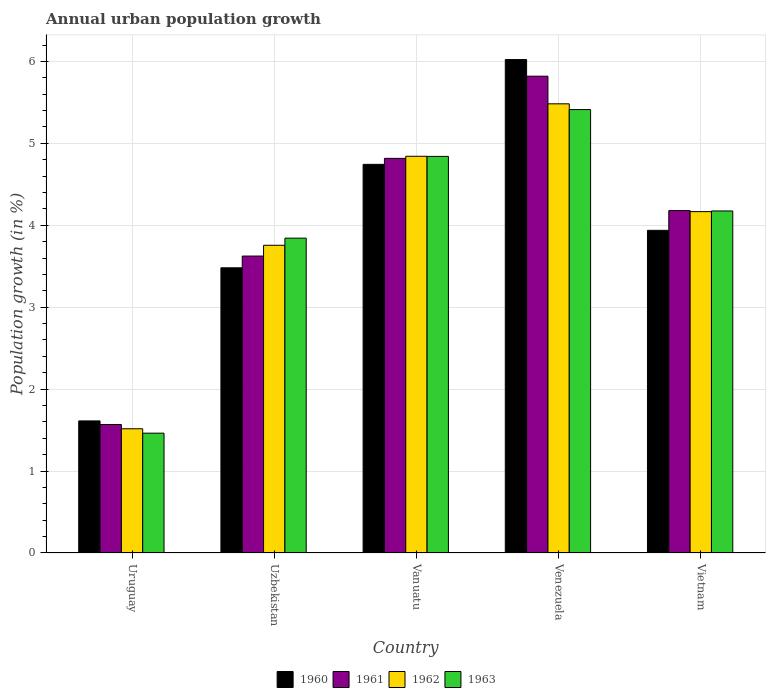Are the number of bars per tick equal to the number of legend labels?
Your answer should be compact. Yes. How many bars are there on the 2nd tick from the left?
Keep it short and to the point. 4. What is the label of the 5th group of bars from the left?
Your answer should be compact. Vietnam. What is the percentage of urban population growth in 1963 in Uzbekistan?
Provide a short and direct response. 3.84. Across all countries, what is the maximum percentage of urban population growth in 1962?
Ensure brevity in your answer.  5.48. Across all countries, what is the minimum percentage of urban population growth in 1962?
Your answer should be compact. 1.52. In which country was the percentage of urban population growth in 1962 maximum?
Keep it short and to the point. Venezuela. In which country was the percentage of urban population growth in 1961 minimum?
Give a very brief answer. Uruguay. What is the total percentage of urban population growth in 1962 in the graph?
Provide a short and direct response. 19.76. What is the difference between the percentage of urban population growth in 1962 in Uruguay and that in Venezuela?
Provide a succinct answer. -3.97. What is the difference between the percentage of urban population growth in 1962 in Venezuela and the percentage of urban population growth in 1961 in Uruguay?
Offer a very short reply. 3.91. What is the average percentage of urban population growth in 1960 per country?
Your response must be concise. 3.96. What is the difference between the percentage of urban population growth of/in 1960 and percentage of urban population growth of/in 1961 in Uzbekistan?
Give a very brief answer. -0.14. What is the ratio of the percentage of urban population growth in 1961 in Uzbekistan to that in Vietnam?
Make the answer very short. 0.87. Is the percentage of urban population growth in 1961 in Venezuela less than that in Vietnam?
Provide a short and direct response. No. Is the difference between the percentage of urban population growth in 1960 in Uzbekistan and Vanuatu greater than the difference between the percentage of urban population growth in 1961 in Uzbekistan and Vanuatu?
Keep it short and to the point. No. What is the difference between the highest and the second highest percentage of urban population growth in 1962?
Provide a succinct answer. -0.68. What is the difference between the highest and the lowest percentage of urban population growth in 1960?
Give a very brief answer. 4.41. In how many countries, is the percentage of urban population growth in 1963 greater than the average percentage of urban population growth in 1963 taken over all countries?
Provide a succinct answer. 3. What does the 2nd bar from the right in Vietnam represents?
Provide a short and direct response. 1962. How many bars are there?
Provide a short and direct response. 20. Are the values on the major ticks of Y-axis written in scientific E-notation?
Your response must be concise. No. Does the graph contain any zero values?
Your answer should be compact. No. Does the graph contain grids?
Your answer should be very brief. Yes. How are the legend labels stacked?
Give a very brief answer. Horizontal. What is the title of the graph?
Your response must be concise. Annual urban population growth. What is the label or title of the Y-axis?
Offer a terse response. Population growth (in %). What is the Population growth (in %) in 1960 in Uruguay?
Offer a terse response. 1.61. What is the Population growth (in %) in 1961 in Uruguay?
Provide a succinct answer. 1.57. What is the Population growth (in %) of 1962 in Uruguay?
Provide a succinct answer. 1.52. What is the Population growth (in %) in 1963 in Uruguay?
Make the answer very short. 1.46. What is the Population growth (in %) in 1960 in Uzbekistan?
Give a very brief answer. 3.48. What is the Population growth (in %) of 1961 in Uzbekistan?
Give a very brief answer. 3.62. What is the Population growth (in %) of 1962 in Uzbekistan?
Provide a short and direct response. 3.76. What is the Population growth (in %) of 1963 in Uzbekistan?
Your response must be concise. 3.84. What is the Population growth (in %) in 1960 in Vanuatu?
Your response must be concise. 4.74. What is the Population growth (in %) in 1961 in Vanuatu?
Offer a terse response. 4.82. What is the Population growth (in %) in 1962 in Vanuatu?
Your response must be concise. 4.84. What is the Population growth (in %) of 1963 in Vanuatu?
Your response must be concise. 4.84. What is the Population growth (in %) in 1960 in Venezuela?
Offer a very short reply. 6.02. What is the Population growth (in %) in 1961 in Venezuela?
Keep it short and to the point. 5.82. What is the Population growth (in %) of 1962 in Venezuela?
Offer a very short reply. 5.48. What is the Population growth (in %) of 1963 in Venezuela?
Provide a succinct answer. 5.41. What is the Population growth (in %) of 1960 in Vietnam?
Provide a succinct answer. 3.94. What is the Population growth (in %) of 1961 in Vietnam?
Your response must be concise. 4.18. What is the Population growth (in %) of 1962 in Vietnam?
Keep it short and to the point. 4.17. What is the Population growth (in %) of 1963 in Vietnam?
Your answer should be compact. 4.17. Across all countries, what is the maximum Population growth (in %) in 1960?
Offer a terse response. 6.02. Across all countries, what is the maximum Population growth (in %) of 1961?
Offer a terse response. 5.82. Across all countries, what is the maximum Population growth (in %) of 1962?
Provide a succinct answer. 5.48. Across all countries, what is the maximum Population growth (in %) in 1963?
Keep it short and to the point. 5.41. Across all countries, what is the minimum Population growth (in %) in 1960?
Offer a very short reply. 1.61. Across all countries, what is the minimum Population growth (in %) in 1961?
Offer a very short reply. 1.57. Across all countries, what is the minimum Population growth (in %) of 1962?
Provide a succinct answer. 1.52. Across all countries, what is the minimum Population growth (in %) in 1963?
Your answer should be compact. 1.46. What is the total Population growth (in %) in 1960 in the graph?
Provide a short and direct response. 19.8. What is the total Population growth (in %) in 1961 in the graph?
Make the answer very short. 20.01. What is the total Population growth (in %) of 1962 in the graph?
Keep it short and to the point. 19.76. What is the total Population growth (in %) of 1963 in the graph?
Your answer should be compact. 19.73. What is the difference between the Population growth (in %) of 1960 in Uruguay and that in Uzbekistan?
Make the answer very short. -1.87. What is the difference between the Population growth (in %) in 1961 in Uruguay and that in Uzbekistan?
Offer a terse response. -2.06. What is the difference between the Population growth (in %) of 1962 in Uruguay and that in Uzbekistan?
Offer a very short reply. -2.24. What is the difference between the Population growth (in %) of 1963 in Uruguay and that in Uzbekistan?
Provide a succinct answer. -2.38. What is the difference between the Population growth (in %) in 1960 in Uruguay and that in Vanuatu?
Make the answer very short. -3.13. What is the difference between the Population growth (in %) of 1961 in Uruguay and that in Vanuatu?
Offer a very short reply. -3.25. What is the difference between the Population growth (in %) in 1962 in Uruguay and that in Vanuatu?
Keep it short and to the point. -3.33. What is the difference between the Population growth (in %) in 1963 in Uruguay and that in Vanuatu?
Your response must be concise. -3.38. What is the difference between the Population growth (in %) of 1960 in Uruguay and that in Venezuela?
Give a very brief answer. -4.41. What is the difference between the Population growth (in %) in 1961 in Uruguay and that in Venezuela?
Make the answer very short. -4.25. What is the difference between the Population growth (in %) of 1962 in Uruguay and that in Venezuela?
Provide a succinct answer. -3.97. What is the difference between the Population growth (in %) in 1963 in Uruguay and that in Venezuela?
Keep it short and to the point. -3.95. What is the difference between the Population growth (in %) in 1960 in Uruguay and that in Vietnam?
Your answer should be compact. -2.33. What is the difference between the Population growth (in %) in 1961 in Uruguay and that in Vietnam?
Make the answer very short. -2.61. What is the difference between the Population growth (in %) of 1962 in Uruguay and that in Vietnam?
Give a very brief answer. -2.65. What is the difference between the Population growth (in %) of 1963 in Uruguay and that in Vietnam?
Keep it short and to the point. -2.71. What is the difference between the Population growth (in %) in 1960 in Uzbekistan and that in Vanuatu?
Make the answer very short. -1.26. What is the difference between the Population growth (in %) of 1961 in Uzbekistan and that in Vanuatu?
Provide a succinct answer. -1.19. What is the difference between the Population growth (in %) of 1962 in Uzbekistan and that in Vanuatu?
Your response must be concise. -1.09. What is the difference between the Population growth (in %) in 1963 in Uzbekistan and that in Vanuatu?
Give a very brief answer. -1. What is the difference between the Population growth (in %) of 1960 in Uzbekistan and that in Venezuela?
Offer a very short reply. -2.54. What is the difference between the Population growth (in %) of 1961 in Uzbekistan and that in Venezuela?
Your response must be concise. -2.2. What is the difference between the Population growth (in %) of 1962 in Uzbekistan and that in Venezuela?
Offer a very short reply. -1.73. What is the difference between the Population growth (in %) in 1963 in Uzbekistan and that in Venezuela?
Ensure brevity in your answer.  -1.57. What is the difference between the Population growth (in %) in 1960 in Uzbekistan and that in Vietnam?
Your answer should be very brief. -0.46. What is the difference between the Population growth (in %) of 1961 in Uzbekistan and that in Vietnam?
Your answer should be compact. -0.56. What is the difference between the Population growth (in %) in 1962 in Uzbekistan and that in Vietnam?
Keep it short and to the point. -0.41. What is the difference between the Population growth (in %) in 1963 in Uzbekistan and that in Vietnam?
Your response must be concise. -0.33. What is the difference between the Population growth (in %) of 1960 in Vanuatu and that in Venezuela?
Keep it short and to the point. -1.28. What is the difference between the Population growth (in %) in 1961 in Vanuatu and that in Venezuela?
Keep it short and to the point. -1. What is the difference between the Population growth (in %) in 1962 in Vanuatu and that in Venezuela?
Make the answer very short. -0.64. What is the difference between the Population growth (in %) in 1963 in Vanuatu and that in Venezuela?
Offer a terse response. -0.57. What is the difference between the Population growth (in %) of 1960 in Vanuatu and that in Vietnam?
Ensure brevity in your answer.  0.81. What is the difference between the Population growth (in %) in 1961 in Vanuatu and that in Vietnam?
Your answer should be compact. 0.64. What is the difference between the Population growth (in %) of 1962 in Vanuatu and that in Vietnam?
Offer a terse response. 0.68. What is the difference between the Population growth (in %) of 1963 in Vanuatu and that in Vietnam?
Ensure brevity in your answer.  0.67. What is the difference between the Population growth (in %) in 1960 in Venezuela and that in Vietnam?
Provide a short and direct response. 2.08. What is the difference between the Population growth (in %) in 1961 in Venezuela and that in Vietnam?
Provide a succinct answer. 1.64. What is the difference between the Population growth (in %) in 1962 in Venezuela and that in Vietnam?
Your response must be concise. 1.32. What is the difference between the Population growth (in %) of 1963 in Venezuela and that in Vietnam?
Your answer should be compact. 1.24. What is the difference between the Population growth (in %) in 1960 in Uruguay and the Population growth (in %) in 1961 in Uzbekistan?
Provide a short and direct response. -2.01. What is the difference between the Population growth (in %) of 1960 in Uruguay and the Population growth (in %) of 1962 in Uzbekistan?
Your answer should be very brief. -2.14. What is the difference between the Population growth (in %) of 1960 in Uruguay and the Population growth (in %) of 1963 in Uzbekistan?
Your answer should be very brief. -2.23. What is the difference between the Population growth (in %) of 1961 in Uruguay and the Population growth (in %) of 1962 in Uzbekistan?
Keep it short and to the point. -2.19. What is the difference between the Population growth (in %) in 1961 in Uruguay and the Population growth (in %) in 1963 in Uzbekistan?
Ensure brevity in your answer.  -2.27. What is the difference between the Population growth (in %) of 1962 in Uruguay and the Population growth (in %) of 1963 in Uzbekistan?
Ensure brevity in your answer.  -2.33. What is the difference between the Population growth (in %) in 1960 in Uruguay and the Population growth (in %) in 1961 in Vanuatu?
Provide a succinct answer. -3.2. What is the difference between the Population growth (in %) of 1960 in Uruguay and the Population growth (in %) of 1962 in Vanuatu?
Offer a very short reply. -3.23. What is the difference between the Population growth (in %) in 1960 in Uruguay and the Population growth (in %) in 1963 in Vanuatu?
Your answer should be compact. -3.23. What is the difference between the Population growth (in %) in 1961 in Uruguay and the Population growth (in %) in 1962 in Vanuatu?
Offer a very short reply. -3.27. What is the difference between the Population growth (in %) in 1961 in Uruguay and the Population growth (in %) in 1963 in Vanuatu?
Offer a terse response. -3.27. What is the difference between the Population growth (in %) in 1962 in Uruguay and the Population growth (in %) in 1963 in Vanuatu?
Ensure brevity in your answer.  -3.32. What is the difference between the Population growth (in %) in 1960 in Uruguay and the Population growth (in %) in 1961 in Venezuela?
Provide a succinct answer. -4.21. What is the difference between the Population growth (in %) of 1960 in Uruguay and the Population growth (in %) of 1962 in Venezuela?
Provide a short and direct response. -3.87. What is the difference between the Population growth (in %) of 1960 in Uruguay and the Population growth (in %) of 1963 in Venezuela?
Provide a short and direct response. -3.8. What is the difference between the Population growth (in %) in 1961 in Uruguay and the Population growth (in %) in 1962 in Venezuela?
Offer a terse response. -3.91. What is the difference between the Population growth (in %) of 1961 in Uruguay and the Population growth (in %) of 1963 in Venezuela?
Your response must be concise. -3.84. What is the difference between the Population growth (in %) of 1962 in Uruguay and the Population growth (in %) of 1963 in Venezuela?
Offer a terse response. -3.9. What is the difference between the Population growth (in %) of 1960 in Uruguay and the Population growth (in %) of 1961 in Vietnam?
Provide a short and direct response. -2.57. What is the difference between the Population growth (in %) in 1960 in Uruguay and the Population growth (in %) in 1962 in Vietnam?
Your answer should be very brief. -2.55. What is the difference between the Population growth (in %) in 1960 in Uruguay and the Population growth (in %) in 1963 in Vietnam?
Provide a succinct answer. -2.56. What is the difference between the Population growth (in %) of 1961 in Uruguay and the Population growth (in %) of 1962 in Vietnam?
Offer a very short reply. -2.6. What is the difference between the Population growth (in %) of 1961 in Uruguay and the Population growth (in %) of 1963 in Vietnam?
Offer a very short reply. -2.61. What is the difference between the Population growth (in %) of 1962 in Uruguay and the Population growth (in %) of 1963 in Vietnam?
Keep it short and to the point. -2.66. What is the difference between the Population growth (in %) in 1960 in Uzbekistan and the Population growth (in %) in 1961 in Vanuatu?
Your answer should be very brief. -1.34. What is the difference between the Population growth (in %) in 1960 in Uzbekistan and the Population growth (in %) in 1962 in Vanuatu?
Offer a very short reply. -1.36. What is the difference between the Population growth (in %) of 1960 in Uzbekistan and the Population growth (in %) of 1963 in Vanuatu?
Your response must be concise. -1.36. What is the difference between the Population growth (in %) in 1961 in Uzbekistan and the Population growth (in %) in 1962 in Vanuatu?
Offer a terse response. -1.22. What is the difference between the Population growth (in %) in 1961 in Uzbekistan and the Population growth (in %) in 1963 in Vanuatu?
Make the answer very short. -1.22. What is the difference between the Population growth (in %) of 1962 in Uzbekistan and the Population growth (in %) of 1963 in Vanuatu?
Your response must be concise. -1.08. What is the difference between the Population growth (in %) of 1960 in Uzbekistan and the Population growth (in %) of 1961 in Venezuela?
Provide a short and direct response. -2.34. What is the difference between the Population growth (in %) of 1960 in Uzbekistan and the Population growth (in %) of 1962 in Venezuela?
Keep it short and to the point. -2. What is the difference between the Population growth (in %) in 1960 in Uzbekistan and the Population growth (in %) in 1963 in Venezuela?
Provide a succinct answer. -1.93. What is the difference between the Population growth (in %) in 1961 in Uzbekistan and the Population growth (in %) in 1962 in Venezuela?
Provide a succinct answer. -1.86. What is the difference between the Population growth (in %) of 1961 in Uzbekistan and the Population growth (in %) of 1963 in Venezuela?
Your answer should be compact. -1.79. What is the difference between the Population growth (in %) of 1962 in Uzbekistan and the Population growth (in %) of 1963 in Venezuela?
Provide a succinct answer. -1.66. What is the difference between the Population growth (in %) in 1960 in Uzbekistan and the Population growth (in %) in 1961 in Vietnam?
Keep it short and to the point. -0.7. What is the difference between the Population growth (in %) of 1960 in Uzbekistan and the Population growth (in %) of 1962 in Vietnam?
Make the answer very short. -0.69. What is the difference between the Population growth (in %) in 1960 in Uzbekistan and the Population growth (in %) in 1963 in Vietnam?
Provide a short and direct response. -0.69. What is the difference between the Population growth (in %) in 1961 in Uzbekistan and the Population growth (in %) in 1962 in Vietnam?
Your answer should be compact. -0.54. What is the difference between the Population growth (in %) in 1961 in Uzbekistan and the Population growth (in %) in 1963 in Vietnam?
Provide a succinct answer. -0.55. What is the difference between the Population growth (in %) in 1962 in Uzbekistan and the Population growth (in %) in 1963 in Vietnam?
Offer a terse response. -0.42. What is the difference between the Population growth (in %) of 1960 in Vanuatu and the Population growth (in %) of 1961 in Venezuela?
Offer a very short reply. -1.08. What is the difference between the Population growth (in %) in 1960 in Vanuatu and the Population growth (in %) in 1962 in Venezuela?
Give a very brief answer. -0.74. What is the difference between the Population growth (in %) of 1960 in Vanuatu and the Population growth (in %) of 1963 in Venezuela?
Give a very brief answer. -0.67. What is the difference between the Population growth (in %) in 1961 in Vanuatu and the Population growth (in %) in 1962 in Venezuela?
Provide a succinct answer. -0.67. What is the difference between the Population growth (in %) of 1961 in Vanuatu and the Population growth (in %) of 1963 in Venezuela?
Give a very brief answer. -0.6. What is the difference between the Population growth (in %) of 1962 in Vanuatu and the Population growth (in %) of 1963 in Venezuela?
Ensure brevity in your answer.  -0.57. What is the difference between the Population growth (in %) in 1960 in Vanuatu and the Population growth (in %) in 1961 in Vietnam?
Keep it short and to the point. 0.56. What is the difference between the Population growth (in %) in 1960 in Vanuatu and the Population growth (in %) in 1962 in Vietnam?
Your answer should be compact. 0.58. What is the difference between the Population growth (in %) in 1960 in Vanuatu and the Population growth (in %) in 1963 in Vietnam?
Your answer should be compact. 0.57. What is the difference between the Population growth (in %) in 1961 in Vanuatu and the Population growth (in %) in 1962 in Vietnam?
Keep it short and to the point. 0.65. What is the difference between the Population growth (in %) of 1961 in Vanuatu and the Population growth (in %) of 1963 in Vietnam?
Your answer should be compact. 0.64. What is the difference between the Population growth (in %) of 1962 in Vanuatu and the Population growth (in %) of 1963 in Vietnam?
Your response must be concise. 0.67. What is the difference between the Population growth (in %) of 1960 in Venezuela and the Population growth (in %) of 1961 in Vietnam?
Offer a very short reply. 1.84. What is the difference between the Population growth (in %) of 1960 in Venezuela and the Population growth (in %) of 1962 in Vietnam?
Make the answer very short. 1.86. What is the difference between the Population growth (in %) of 1960 in Venezuela and the Population growth (in %) of 1963 in Vietnam?
Offer a terse response. 1.85. What is the difference between the Population growth (in %) of 1961 in Venezuela and the Population growth (in %) of 1962 in Vietnam?
Make the answer very short. 1.65. What is the difference between the Population growth (in %) in 1961 in Venezuela and the Population growth (in %) in 1963 in Vietnam?
Provide a short and direct response. 1.64. What is the difference between the Population growth (in %) in 1962 in Venezuela and the Population growth (in %) in 1963 in Vietnam?
Offer a very short reply. 1.31. What is the average Population growth (in %) of 1960 per country?
Make the answer very short. 3.96. What is the average Population growth (in %) in 1961 per country?
Provide a short and direct response. 4. What is the average Population growth (in %) of 1962 per country?
Keep it short and to the point. 3.95. What is the average Population growth (in %) of 1963 per country?
Your response must be concise. 3.95. What is the difference between the Population growth (in %) in 1960 and Population growth (in %) in 1961 in Uruguay?
Keep it short and to the point. 0.04. What is the difference between the Population growth (in %) of 1960 and Population growth (in %) of 1962 in Uruguay?
Keep it short and to the point. 0.1. What is the difference between the Population growth (in %) in 1960 and Population growth (in %) in 1963 in Uruguay?
Provide a succinct answer. 0.15. What is the difference between the Population growth (in %) of 1961 and Population growth (in %) of 1962 in Uruguay?
Provide a short and direct response. 0.05. What is the difference between the Population growth (in %) in 1961 and Population growth (in %) in 1963 in Uruguay?
Offer a very short reply. 0.11. What is the difference between the Population growth (in %) in 1962 and Population growth (in %) in 1963 in Uruguay?
Offer a very short reply. 0.05. What is the difference between the Population growth (in %) of 1960 and Population growth (in %) of 1961 in Uzbekistan?
Make the answer very short. -0.14. What is the difference between the Population growth (in %) of 1960 and Population growth (in %) of 1962 in Uzbekistan?
Provide a succinct answer. -0.28. What is the difference between the Population growth (in %) of 1960 and Population growth (in %) of 1963 in Uzbekistan?
Ensure brevity in your answer.  -0.36. What is the difference between the Population growth (in %) in 1961 and Population growth (in %) in 1962 in Uzbekistan?
Make the answer very short. -0.13. What is the difference between the Population growth (in %) of 1961 and Population growth (in %) of 1963 in Uzbekistan?
Provide a short and direct response. -0.22. What is the difference between the Population growth (in %) in 1962 and Population growth (in %) in 1963 in Uzbekistan?
Your answer should be compact. -0.09. What is the difference between the Population growth (in %) in 1960 and Population growth (in %) in 1961 in Vanuatu?
Ensure brevity in your answer.  -0.07. What is the difference between the Population growth (in %) of 1960 and Population growth (in %) of 1962 in Vanuatu?
Provide a short and direct response. -0.1. What is the difference between the Population growth (in %) of 1960 and Population growth (in %) of 1963 in Vanuatu?
Your answer should be compact. -0.1. What is the difference between the Population growth (in %) in 1961 and Population growth (in %) in 1962 in Vanuatu?
Provide a succinct answer. -0.03. What is the difference between the Population growth (in %) of 1961 and Population growth (in %) of 1963 in Vanuatu?
Give a very brief answer. -0.02. What is the difference between the Population growth (in %) of 1962 and Population growth (in %) of 1963 in Vanuatu?
Your answer should be very brief. 0. What is the difference between the Population growth (in %) of 1960 and Population growth (in %) of 1961 in Venezuela?
Ensure brevity in your answer.  0.2. What is the difference between the Population growth (in %) of 1960 and Population growth (in %) of 1962 in Venezuela?
Ensure brevity in your answer.  0.54. What is the difference between the Population growth (in %) of 1960 and Population growth (in %) of 1963 in Venezuela?
Provide a succinct answer. 0.61. What is the difference between the Population growth (in %) in 1961 and Population growth (in %) in 1962 in Venezuela?
Provide a short and direct response. 0.34. What is the difference between the Population growth (in %) in 1961 and Population growth (in %) in 1963 in Venezuela?
Offer a terse response. 0.41. What is the difference between the Population growth (in %) of 1962 and Population growth (in %) of 1963 in Venezuela?
Provide a succinct answer. 0.07. What is the difference between the Population growth (in %) of 1960 and Population growth (in %) of 1961 in Vietnam?
Keep it short and to the point. -0.24. What is the difference between the Population growth (in %) in 1960 and Population growth (in %) in 1962 in Vietnam?
Offer a terse response. -0.23. What is the difference between the Population growth (in %) of 1960 and Population growth (in %) of 1963 in Vietnam?
Offer a very short reply. -0.24. What is the difference between the Population growth (in %) in 1961 and Population growth (in %) in 1962 in Vietnam?
Keep it short and to the point. 0.01. What is the difference between the Population growth (in %) of 1961 and Population growth (in %) of 1963 in Vietnam?
Keep it short and to the point. 0. What is the difference between the Population growth (in %) of 1962 and Population growth (in %) of 1963 in Vietnam?
Give a very brief answer. -0.01. What is the ratio of the Population growth (in %) of 1960 in Uruguay to that in Uzbekistan?
Give a very brief answer. 0.46. What is the ratio of the Population growth (in %) of 1961 in Uruguay to that in Uzbekistan?
Your response must be concise. 0.43. What is the ratio of the Population growth (in %) of 1962 in Uruguay to that in Uzbekistan?
Ensure brevity in your answer.  0.4. What is the ratio of the Population growth (in %) in 1963 in Uruguay to that in Uzbekistan?
Ensure brevity in your answer.  0.38. What is the ratio of the Population growth (in %) in 1960 in Uruguay to that in Vanuatu?
Keep it short and to the point. 0.34. What is the ratio of the Population growth (in %) in 1961 in Uruguay to that in Vanuatu?
Provide a short and direct response. 0.33. What is the ratio of the Population growth (in %) of 1962 in Uruguay to that in Vanuatu?
Offer a terse response. 0.31. What is the ratio of the Population growth (in %) of 1963 in Uruguay to that in Vanuatu?
Your response must be concise. 0.3. What is the ratio of the Population growth (in %) in 1960 in Uruguay to that in Venezuela?
Make the answer very short. 0.27. What is the ratio of the Population growth (in %) in 1961 in Uruguay to that in Venezuela?
Make the answer very short. 0.27. What is the ratio of the Population growth (in %) of 1962 in Uruguay to that in Venezuela?
Your response must be concise. 0.28. What is the ratio of the Population growth (in %) in 1963 in Uruguay to that in Venezuela?
Ensure brevity in your answer.  0.27. What is the ratio of the Population growth (in %) in 1960 in Uruguay to that in Vietnam?
Provide a succinct answer. 0.41. What is the ratio of the Population growth (in %) in 1961 in Uruguay to that in Vietnam?
Offer a terse response. 0.38. What is the ratio of the Population growth (in %) of 1962 in Uruguay to that in Vietnam?
Keep it short and to the point. 0.36. What is the ratio of the Population growth (in %) of 1963 in Uruguay to that in Vietnam?
Keep it short and to the point. 0.35. What is the ratio of the Population growth (in %) of 1960 in Uzbekistan to that in Vanuatu?
Your answer should be very brief. 0.73. What is the ratio of the Population growth (in %) in 1961 in Uzbekistan to that in Vanuatu?
Offer a very short reply. 0.75. What is the ratio of the Population growth (in %) of 1962 in Uzbekistan to that in Vanuatu?
Offer a very short reply. 0.78. What is the ratio of the Population growth (in %) of 1963 in Uzbekistan to that in Vanuatu?
Ensure brevity in your answer.  0.79. What is the ratio of the Population growth (in %) of 1960 in Uzbekistan to that in Venezuela?
Provide a succinct answer. 0.58. What is the ratio of the Population growth (in %) in 1961 in Uzbekistan to that in Venezuela?
Give a very brief answer. 0.62. What is the ratio of the Population growth (in %) in 1962 in Uzbekistan to that in Venezuela?
Provide a short and direct response. 0.69. What is the ratio of the Population growth (in %) of 1963 in Uzbekistan to that in Venezuela?
Make the answer very short. 0.71. What is the ratio of the Population growth (in %) of 1960 in Uzbekistan to that in Vietnam?
Make the answer very short. 0.88. What is the ratio of the Population growth (in %) in 1961 in Uzbekistan to that in Vietnam?
Make the answer very short. 0.87. What is the ratio of the Population growth (in %) in 1962 in Uzbekistan to that in Vietnam?
Give a very brief answer. 0.9. What is the ratio of the Population growth (in %) of 1963 in Uzbekistan to that in Vietnam?
Provide a succinct answer. 0.92. What is the ratio of the Population growth (in %) of 1960 in Vanuatu to that in Venezuela?
Ensure brevity in your answer.  0.79. What is the ratio of the Population growth (in %) in 1961 in Vanuatu to that in Venezuela?
Offer a very short reply. 0.83. What is the ratio of the Population growth (in %) of 1962 in Vanuatu to that in Venezuela?
Your answer should be compact. 0.88. What is the ratio of the Population growth (in %) of 1963 in Vanuatu to that in Venezuela?
Offer a very short reply. 0.89. What is the ratio of the Population growth (in %) in 1960 in Vanuatu to that in Vietnam?
Make the answer very short. 1.2. What is the ratio of the Population growth (in %) of 1961 in Vanuatu to that in Vietnam?
Your answer should be very brief. 1.15. What is the ratio of the Population growth (in %) of 1962 in Vanuatu to that in Vietnam?
Your answer should be compact. 1.16. What is the ratio of the Population growth (in %) of 1963 in Vanuatu to that in Vietnam?
Provide a short and direct response. 1.16. What is the ratio of the Population growth (in %) in 1960 in Venezuela to that in Vietnam?
Your response must be concise. 1.53. What is the ratio of the Population growth (in %) in 1961 in Venezuela to that in Vietnam?
Offer a terse response. 1.39. What is the ratio of the Population growth (in %) of 1962 in Venezuela to that in Vietnam?
Offer a very short reply. 1.32. What is the ratio of the Population growth (in %) of 1963 in Venezuela to that in Vietnam?
Ensure brevity in your answer.  1.3. What is the difference between the highest and the second highest Population growth (in %) in 1960?
Keep it short and to the point. 1.28. What is the difference between the highest and the second highest Population growth (in %) of 1961?
Keep it short and to the point. 1. What is the difference between the highest and the second highest Population growth (in %) in 1962?
Your response must be concise. 0.64. What is the difference between the highest and the second highest Population growth (in %) of 1963?
Keep it short and to the point. 0.57. What is the difference between the highest and the lowest Population growth (in %) of 1960?
Your answer should be very brief. 4.41. What is the difference between the highest and the lowest Population growth (in %) of 1961?
Offer a terse response. 4.25. What is the difference between the highest and the lowest Population growth (in %) of 1962?
Make the answer very short. 3.97. What is the difference between the highest and the lowest Population growth (in %) in 1963?
Ensure brevity in your answer.  3.95. 